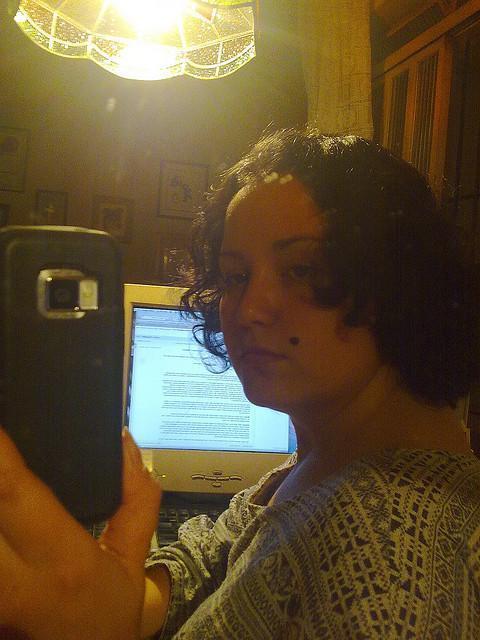What is on the woman's lip who is holding the camera in front of the computer?
Answer the question by selecting the correct answer among the 4 following choices and explain your choice with a short sentence. The answer should be formatted with the following format: `Answer: choice
Rationale: rationale.`
Options: Mole, lipstick, chapstick, glitter. Answer: lipstick.
Rationale: The woman has lipstick on. 